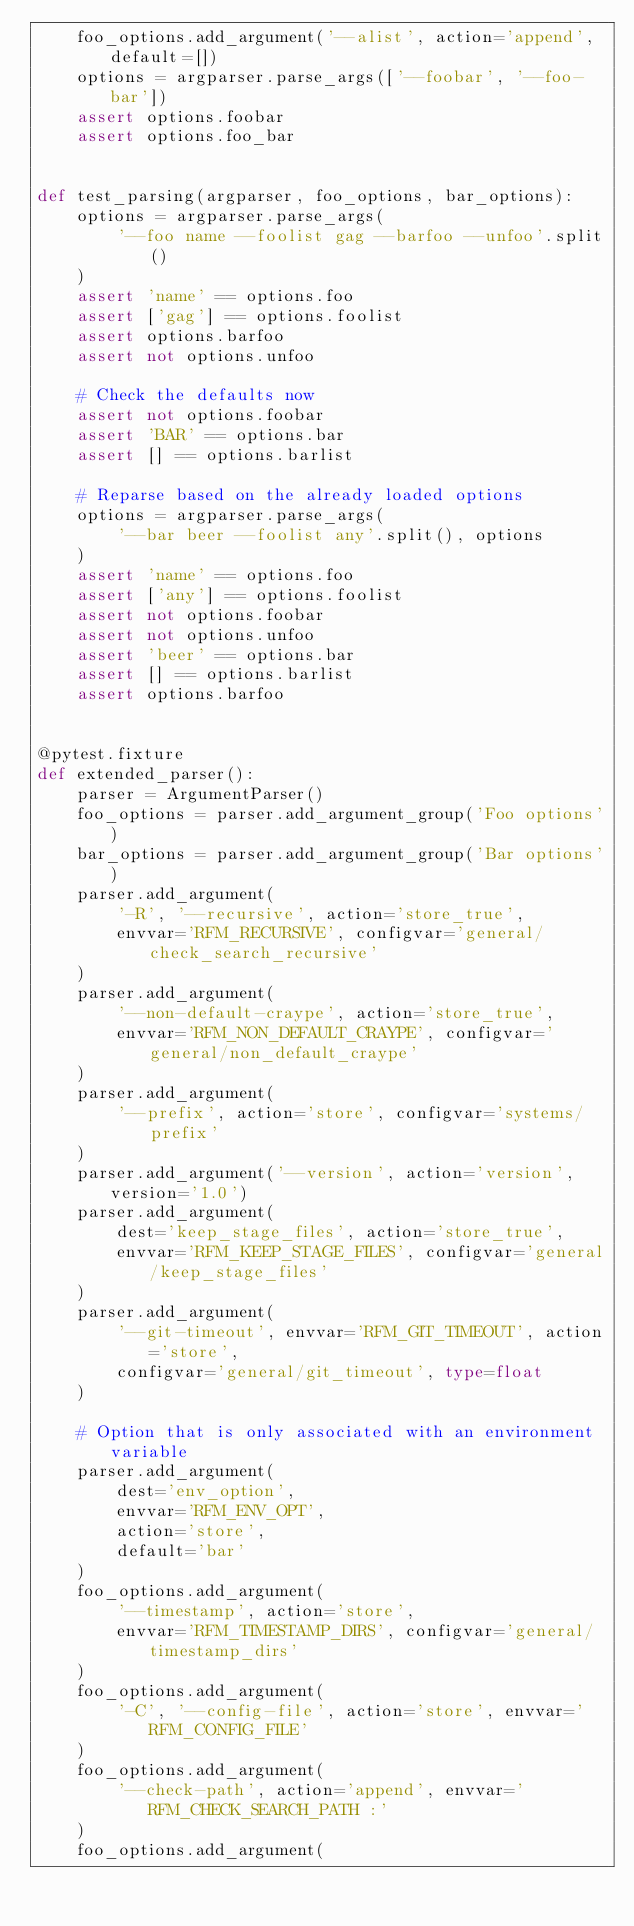<code> <loc_0><loc_0><loc_500><loc_500><_Python_>    foo_options.add_argument('--alist', action='append', default=[])
    options = argparser.parse_args(['--foobar', '--foo-bar'])
    assert options.foobar
    assert options.foo_bar


def test_parsing(argparser, foo_options, bar_options):
    options = argparser.parse_args(
        '--foo name --foolist gag --barfoo --unfoo'.split()
    )
    assert 'name' == options.foo
    assert ['gag'] == options.foolist
    assert options.barfoo
    assert not options.unfoo

    # Check the defaults now
    assert not options.foobar
    assert 'BAR' == options.bar
    assert [] == options.barlist

    # Reparse based on the already loaded options
    options = argparser.parse_args(
        '--bar beer --foolist any'.split(), options
    )
    assert 'name' == options.foo
    assert ['any'] == options.foolist
    assert not options.foobar
    assert not options.unfoo
    assert 'beer' == options.bar
    assert [] == options.barlist
    assert options.barfoo


@pytest.fixture
def extended_parser():
    parser = ArgumentParser()
    foo_options = parser.add_argument_group('Foo options')
    bar_options = parser.add_argument_group('Bar options')
    parser.add_argument(
        '-R', '--recursive', action='store_true',
        envvar='RFM_RECURSIVE', configvar='general/check_search_recursive'
    )
    parser.add_argument(
        '--non-default-craype', action='store_true',
        envvar='RFM_NON_DEFAULT_CRAYPE', configvar='general/non_default_craype'
    )
    parser.add_argument(
        '--prefix', action='store', configvar='systems/prefix'
    )
    parser.add_argument('--version', action='version', version='1.0')
    parser.add_argument(
        dest='keep_stage_files', action='store_true',
        envvar='RFM_KEEP_STAGE_FILES', configvar='general/keep_stage_files'
    )
    parser.add_argument(
        '--git-timeout', envvar='RFM_GIT_TIMEOUT', action='store',
        configvar='general/git_timeout', type=float
    )

    # Option that is only associated with an environment variable
    parser.add_argument(
        dest='env_option',
        envvar='RFM_ENV_OPT',
        action='store',
        default='bar'
    )
    foo_options.add_argument(
        '--timestamp', action='store',
        envvar='RFM_TIMESTAMP_DIRS', configvar='general/timestamp_dirs'
    )
    foo_options.add_argument(
        '-C', '--config-file', action='store', envvar='RFM_CONFIG_FILE'
    )
    foo_options.add_argument(
        '--check-path', action='append', envvar='RFM_CHECK_SEARCH_PATH :'
    )
    foo_options.add_argument(</code> 